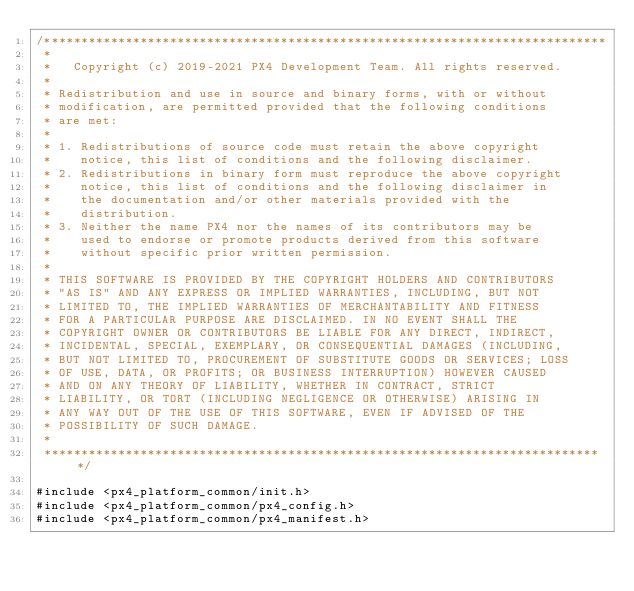Convert code to text. <code><loc_0><loc_0><loc_500><loc_500><_C++_>/****************************************************************************
 *
 *   Copyright (c) 2019-2021 PX4 Development Team. All rights reserved.
 *
 * Redistribution and use in source and binary forms, with or without
 * modification, are permitted provided that the following conditions
 * are met:
 *
 * 1. Redistributions of source code must retain the above copyright
 *    notice, this list of conditions and the following disclaimer.
 * 2. Redistributions in binary form must reproduce the above copyright
 *    notice, this list of conditions and the following disclaimer in
 *    the documentation and/or other materials provided with the
 *    distribution.
 * 3. Neither the name PX4 nor the names of its contributors may be
 *    used to endorse or promote products derived from this software
 *    without specific prior written permission.
 *
 * THIS SOFTWARE IS PROVIDED BY THE COPYRIGHT HOLDERS AND CONTRIBUTORS
 * "AS IS" AND ANY EXPRESS OR IMPLIED WARRANTIES, INCLUDING, BUT NOT
 * LIMITED TO, THE IMPLIED WARRANTIES OF MERCHANTABILITY AND FITNESS
 * FOR A PARTICULAR PURPOSE ARE DISCLAIMED. IN NO EVENT SHALL THE
 * COPYRIGHT OWNER OR CONTRIBUTORS BE LIABLE FOR ANY DIRECT, INDIRECT,
 * INCIDENTAL, SPECIAL, EXEMPLARY, OR CONSEQUENTIAL DAMAGES (INCLUDING,
 * BUT NOT LIMITED TO, PROCUREMENT OF SUBSTITUTE GOODS OR SERVICES; LOSS
 * OF USE, DATA, OR PROFITS; OR BUSINESS INTERRUPTION) HOWEVER CAUSED
 * AND ON ANY THEORY OF LIABILITY, WHETHER IN CONTRACT, STRICT
 * LIABILITY, OR TORT (INCLUDING NEGLIGENCE OR OTHERWISE) ARISING IN
 * ANY WAY OUT OF THE USE OF THIS SOFTWARE, EVEN IF ADVISED OF THE
 * POSSIBILITY OF SUCH DAMAGE.
 *
 ****************************************************************************/

#include <px4_platform_common/init.h>
#include <px4_platform_common/px4_config.h>
#include <px4_platform_common/px4_manifest.h></code> 